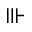<formula> <loc_0><loc_0><loc_500><loc_500>\ V v d a s h</formula> 